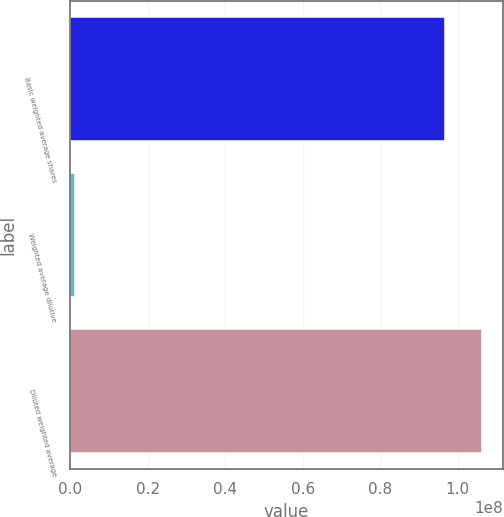Convert chart to OTSL. <chart><loc_0><loc_0><loc_500><loc_500><bar_chart><fcel>Basic weighted average shares<fcel>Weighted average dilutive<fcel>Diluted weighted average<nl><fcel>9.66142e+07<fcel>1.28419e+06<fcel>1.06276e+08<nl></chart> 